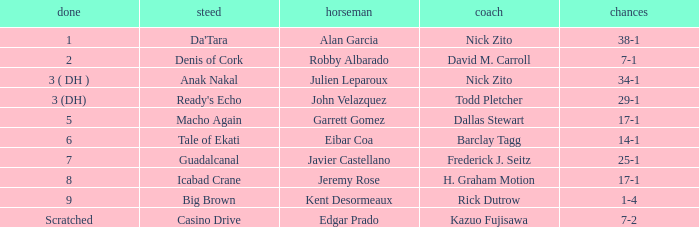Which Horse finished in 8? Icabad Crane. 